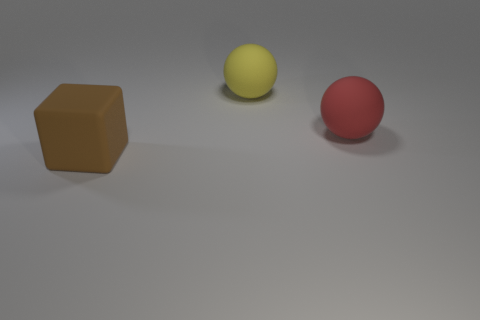Subtract all cyan spheres. Subtract all brown cubes. How many spheres are left? 2 Add 3 big yellow spheres. How many objects exist? 6 Subtract all blocks. How many objects are left? 2 Subtract 0 brown spheres. How many objects are left? 3 Subtract all blue rubber blocks. Subtract all brown cubes. How many objects are left? 2 Add 2 big yellow matte balls. How many big yellow matte balls are left? 3 Add 3 big brown things. How many big brown things exist? 4 